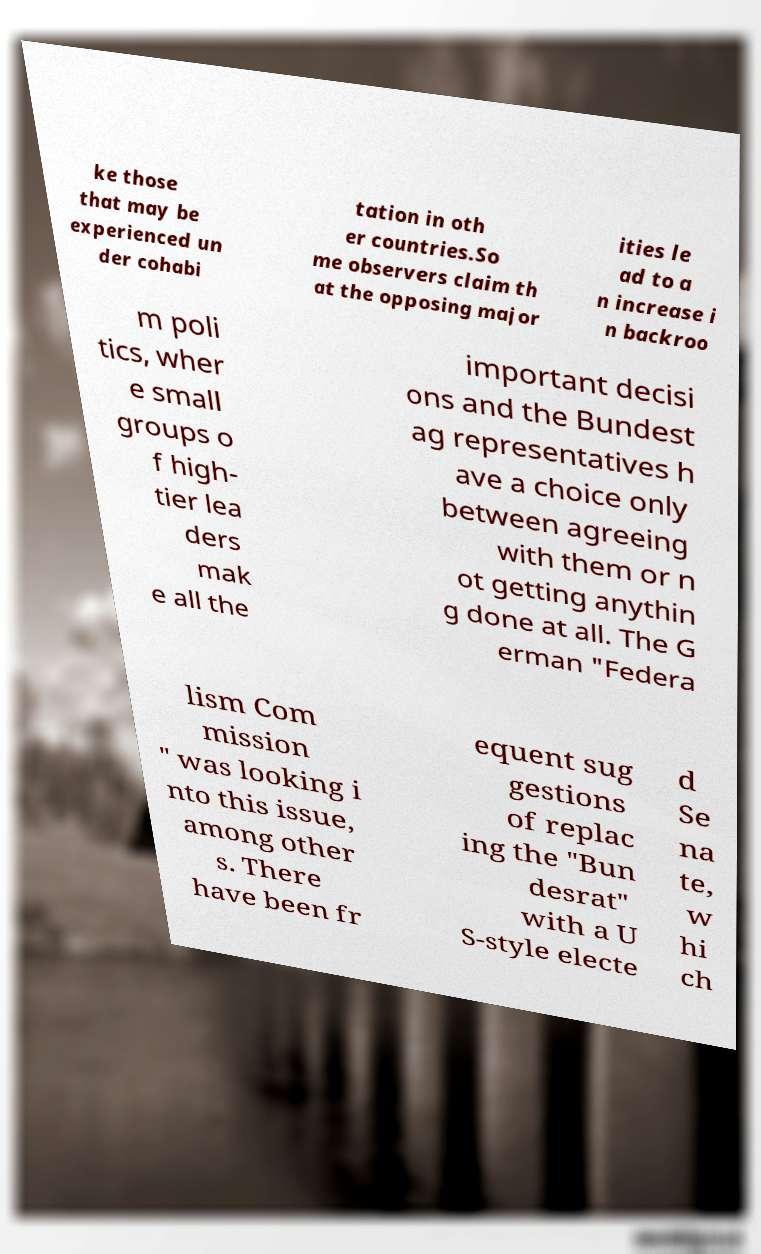I need the written content from this picture converted into text. Can you do that? ke those that may be experienced un der cohabi tation in oth er countries.So me observers claim th at the opposing major ities le ad to a n increase i n backroo m poli tics, wher e small groups o f high- tier lea ders mak e all the important decisi ons and the Bundest ag representatives h ave a choice only between agreeing with them or n ot getting anythin g done at all. The G erman "Federa lism Com mission " was looking i nto this issue, among other s. There have been fr equent sug gestions of replac ing the "Bun desrat" with a U S-style electe d Se na te, w hi ch 